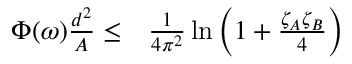Convert formula to latex. <formula><loc_0><loc_0><loc_500><loc_500>\begin{array} { r l } { \Phi ( \omega ) \frac { d ^ { 2 } } { A } \leq } & \frac { 1 } { 4 \pi ^ { 2 } } \ln \left ( 1 + \frac { \zeta _ { A } \zeta _ { B } } { 4 } \right ) } \end{array}</formula> 